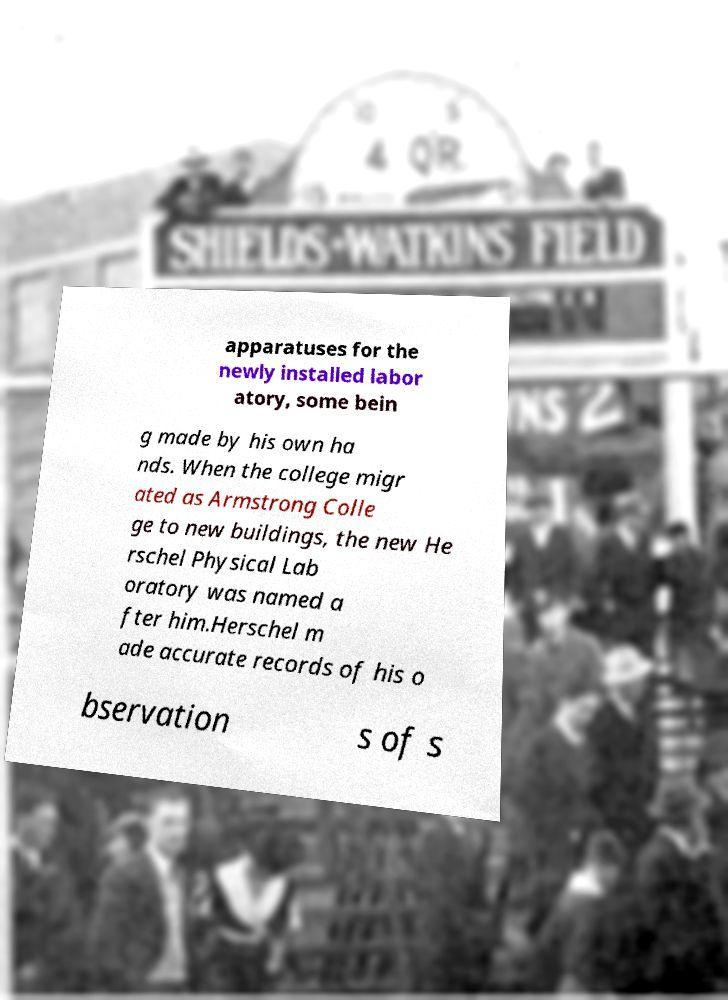Can you accurately transcribe the text from the provided image for me? apparatuses for the newly installed labor atory, some bein g made by his own ha nds. When the college migr ated as Armstrong Colle ge to new buildings, the new He rschel Physical Lab oratory was named a fter him.Herschel m ade accurate records of his o bservation s of s 